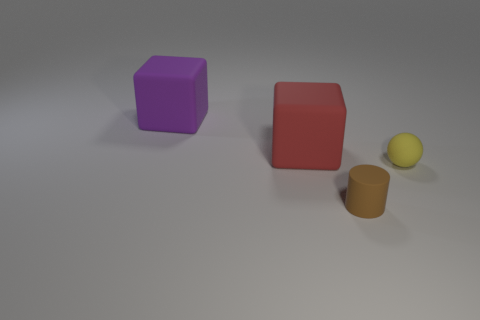Add 4 red rubber cubes. How many objects exist? 8 Subtract all balls. How many objects are left? 3 Subtract 0 blue blocks. How many objects are left? 4 Subtract all small cylinders. Subtract all tiny cylinders. How many objects are left? 2 Add 1 small spheres. How many small spheres are left? 2 Add 1 large purple blocks. How many large purple blocks exist? 2 